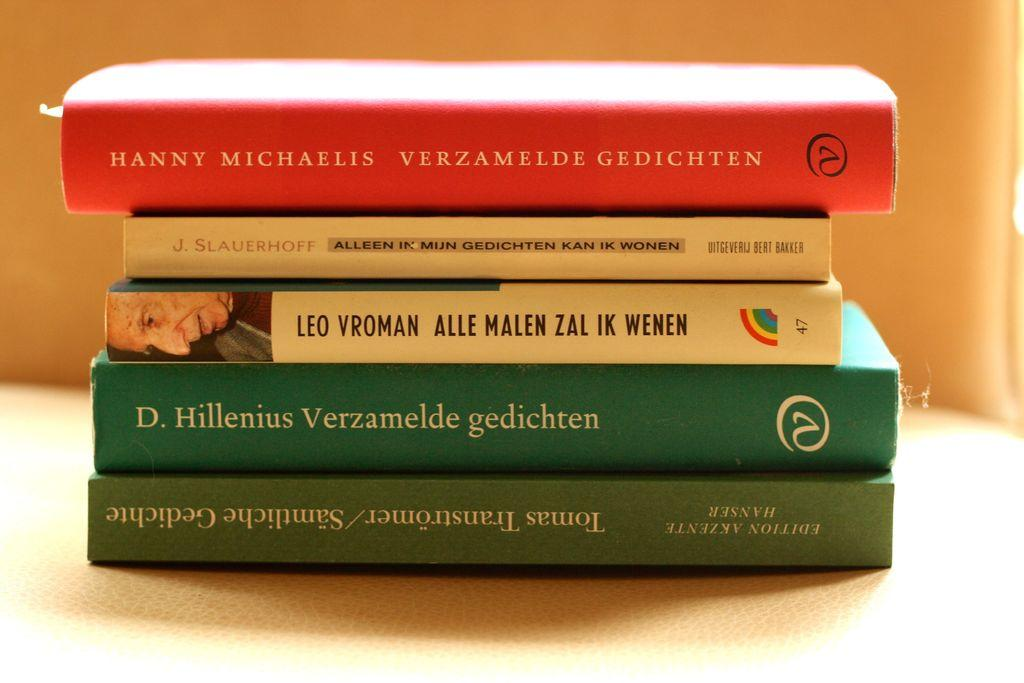Provide a one-sentence caption for the provided image. The stack of books includes "Verzamelde Gedichten", "Alleen In Mijn Gedichten Kan ik Wonen", and "Alle Malen Zal ik Wenen". 